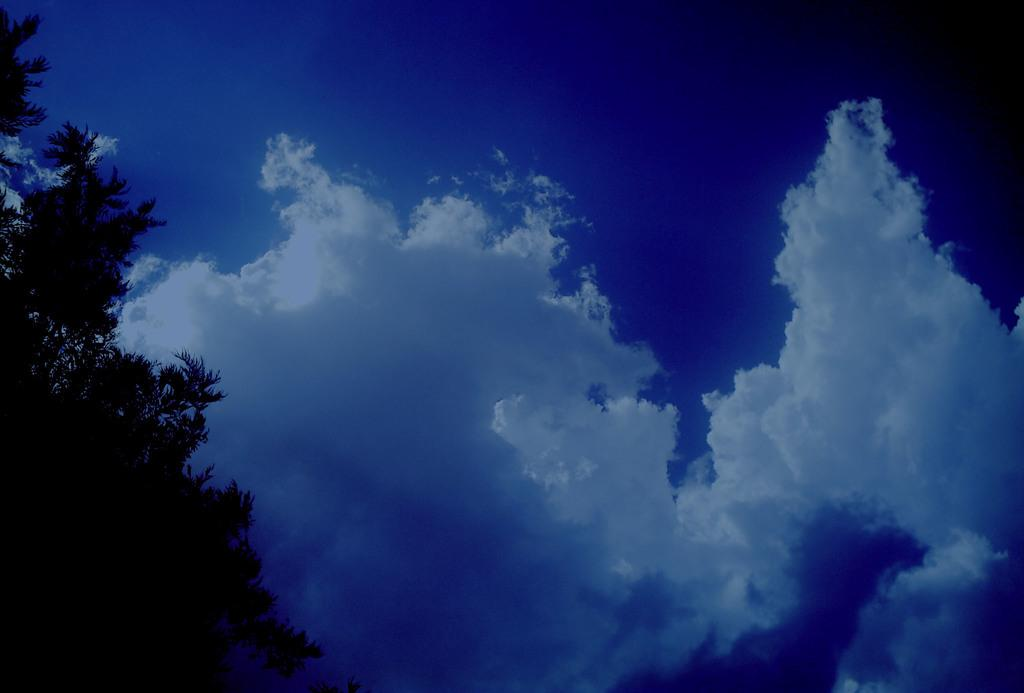What can be seen in the sky in the image? There are clouds in the sky. What is located on the left side of the image? There is a tree with branches and leaves on the left side of the image. What type of cart is visible in the image? There is no cart present in the image. What is the canvas used for in the image? There is no canvas present in the image. 